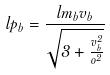<formula> <loc_0><loc_0><loc_500><loc_500>l p _ { b } = \frac { l m _ { b } v _ { b } } { \sqrt { 3 + \frac { v _ { b } ^ { 2 } } { o ^ { 2 } } } }</formula> 